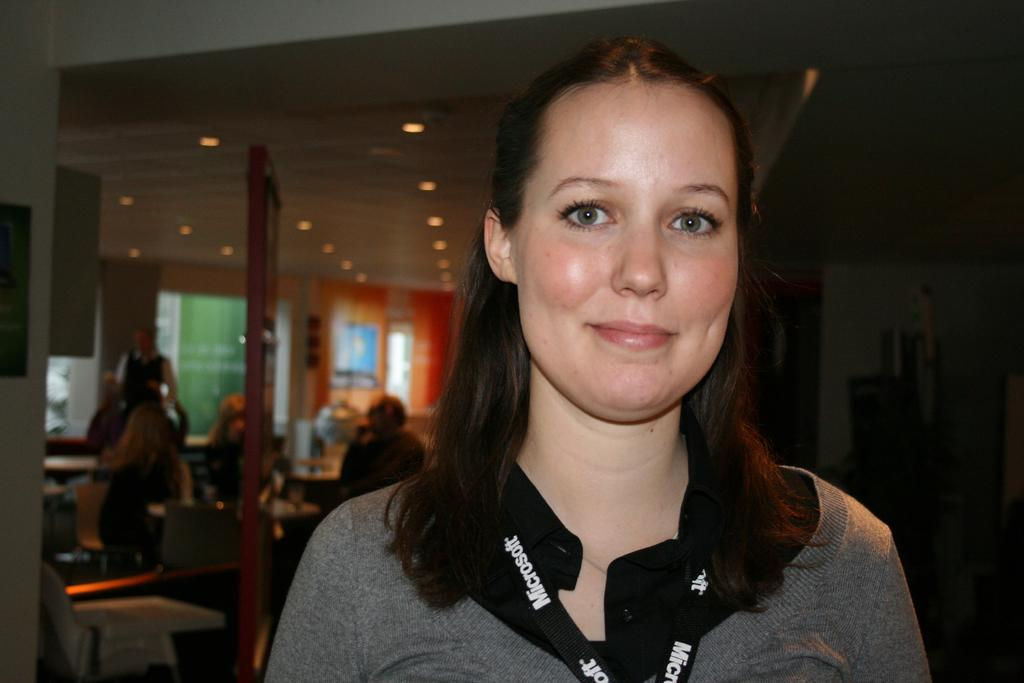<image>
Offer a succinct explanation of the picture presented. A woman is wearing a black Microsoft lanyard around her neck. 